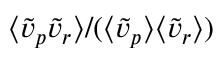<formula> <loc_0><loc_0><loc_500><loc_500>\langle \tilde { v } _ { p } \tilde { v } _ { r } \rangle / ( \langle \tilde { v } _ { p } \rangle \langle \tilde { v } _ { r } \rangle )</formula> 